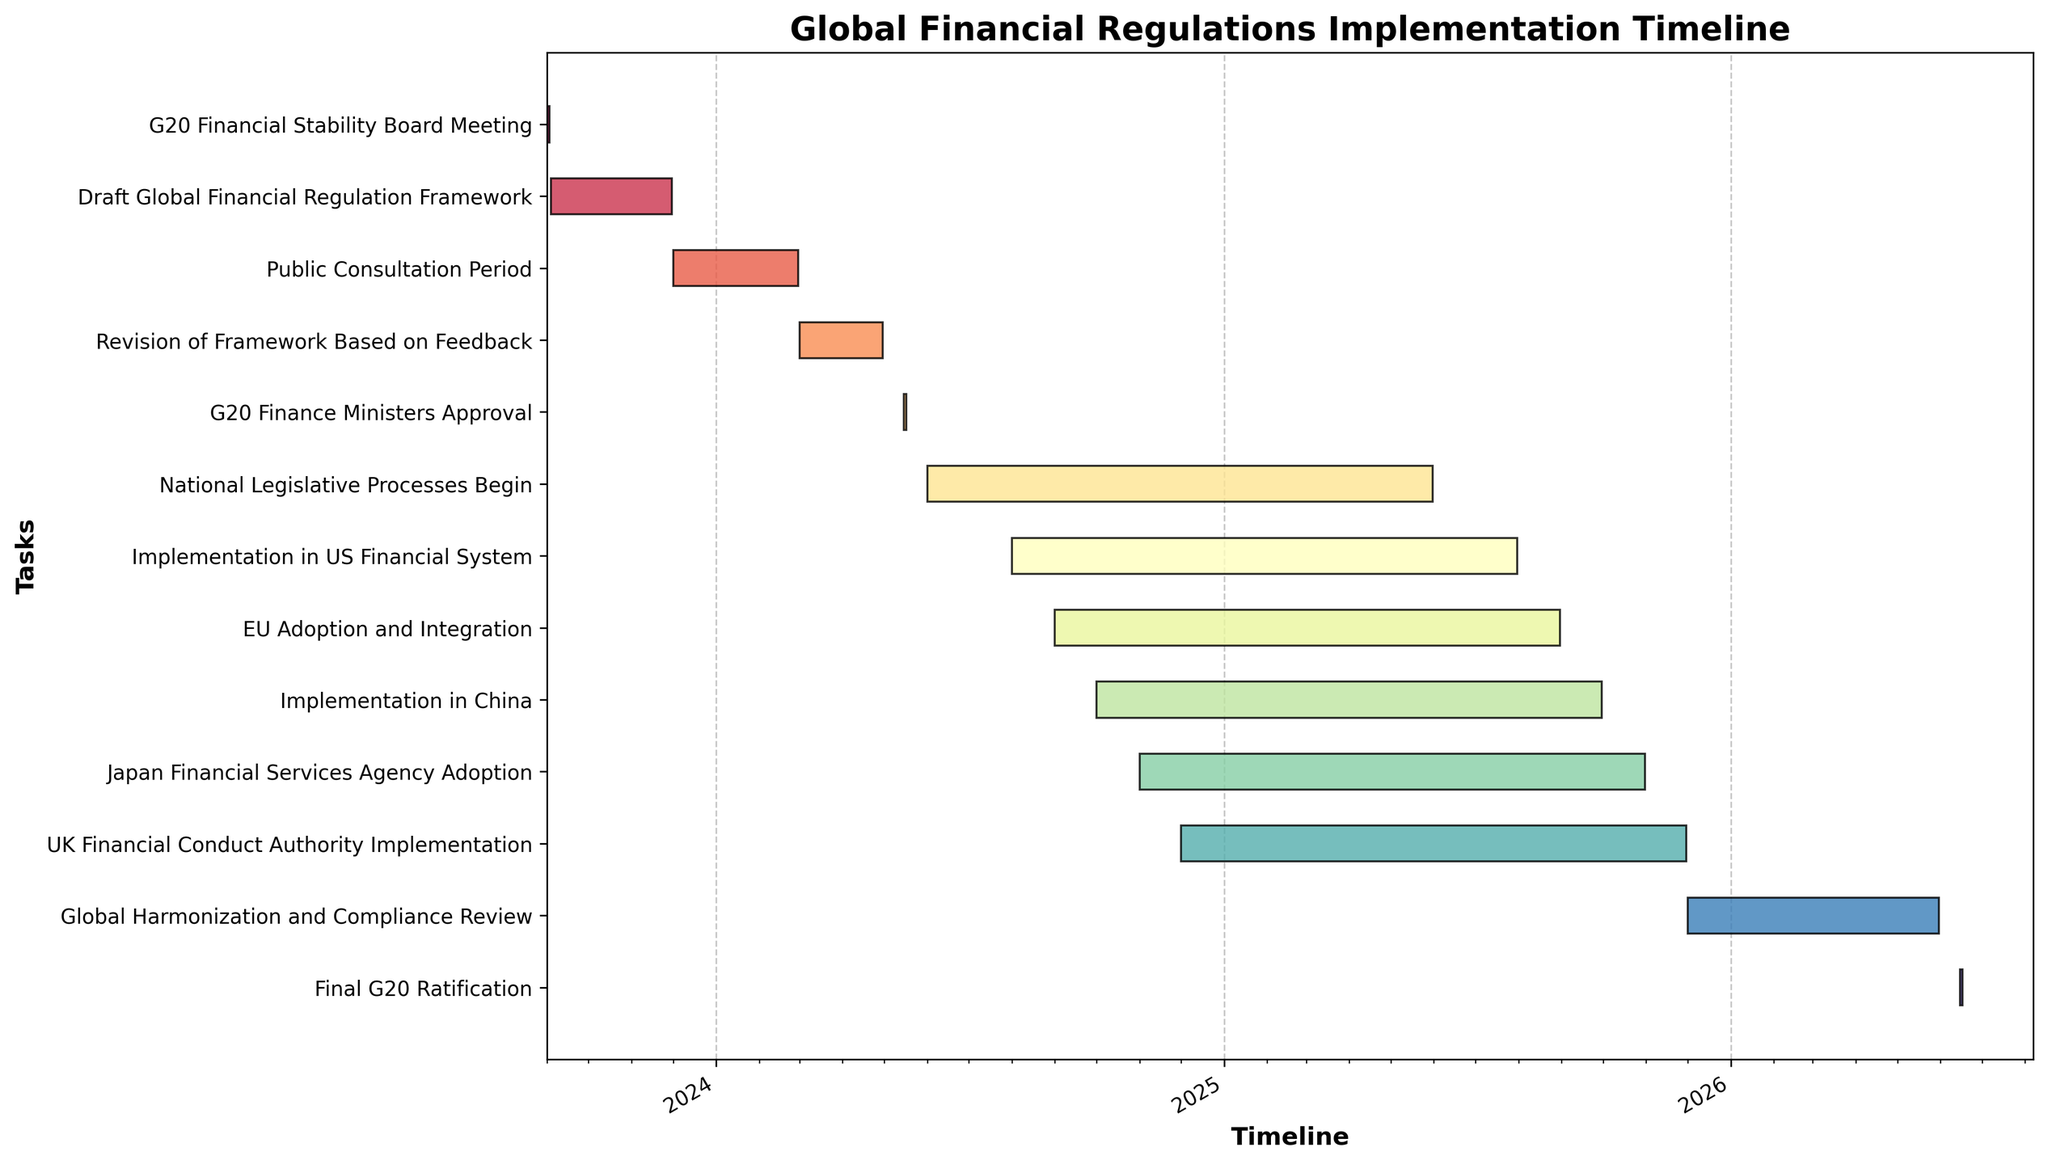what is the title of the figure? The title of the figure is at the top and is clearly visible. It defines the main theme of the Gantt Chart.
Answer: Global Financial Regulations Implementation Timeline What is the duration of the 'Draft Global Financial Regulation Framework' task in months? The 'Draft Global Financial Regulation Framework' task starts on 2023-09-04 and ends on 2023-11-30. To find the duration in months, count the months between the start and end dates. September to November is 3 months.
Answer: 3 months Which task begins right after the 'Public Consultation Period' ends? The 'Public Consultation Period' ends on 2024-02-29. The next task that starts immediately after this date can be identified by looking at the start dates of all tasks. The 'Revision of Framework Based on Feedback' starts on 2024-03-01, which is the next day.
Answer: Revision of Framework Based on Feedback How long is the 'Implementation in China' task in days? The 'Implementation in China' task starts on 2024-10-01 and ends on 2025-09-30. To find the task duration in days, count the days between the start and end dates. This gives a total duration of 365 days (non-leap year).
Answer: 365 days Between 'G20 Finance Ministers Approval' and 'Final G20 Ratification', which task lasts the longest? Calculate the duration of each mentioned task:
- 'G20 Finance Ministers Approval' runs from 2024-05-15 to 2024-05-17, which is 3 days.
- 'Final G20 Ratification' runs from 2026-06-15 to 2026-06-17, which is 3 days.
Both tasks have the same duration.
Answer: Both tasks have the same duration What are the start and end dates for the 'Global Harmonization and Compliance Review' task? The 'Global Harmonization and Compliance Review' task is listed in the Gantt Chart with specific start and end dates. You can find the start and end dates directly from the chart.
Answer: 2025-12-01 to 2026-05-31 Which tasks overlap with the 'G20 Finance Ministers Approval' period? The 'G20 Finance Ministers Approval' is from 2024-05-15 to 2024-05-17. Any tasks that have a start date before 2024-05-17 and an end date after 2024-05-15 will overlap. 'National Legislative Processes Begin' overlaps since it starts on 2024-06-01 but these dates indicate a continuation of activities.
Answer: National Legislative Processes Begin How many tasks are scheduled to start in 2024? Look at the start dates for each task. Count the number of tasks that have start dates in the year 2024. There are 9 tasks starting in 2024:
- Revision of Framework Based on Feedback
- G20 Finance Ministers Approval
- National Legislative Processes Begin
- Implementation in US Financial System
- EU Adoption and Integration
- Implementation in China
- Japan Financial Services Agency Adoption
- UK Financial Conduct Authority Implementation
- Global Harmonization and Compliance Review
Answer: 9 tasks 